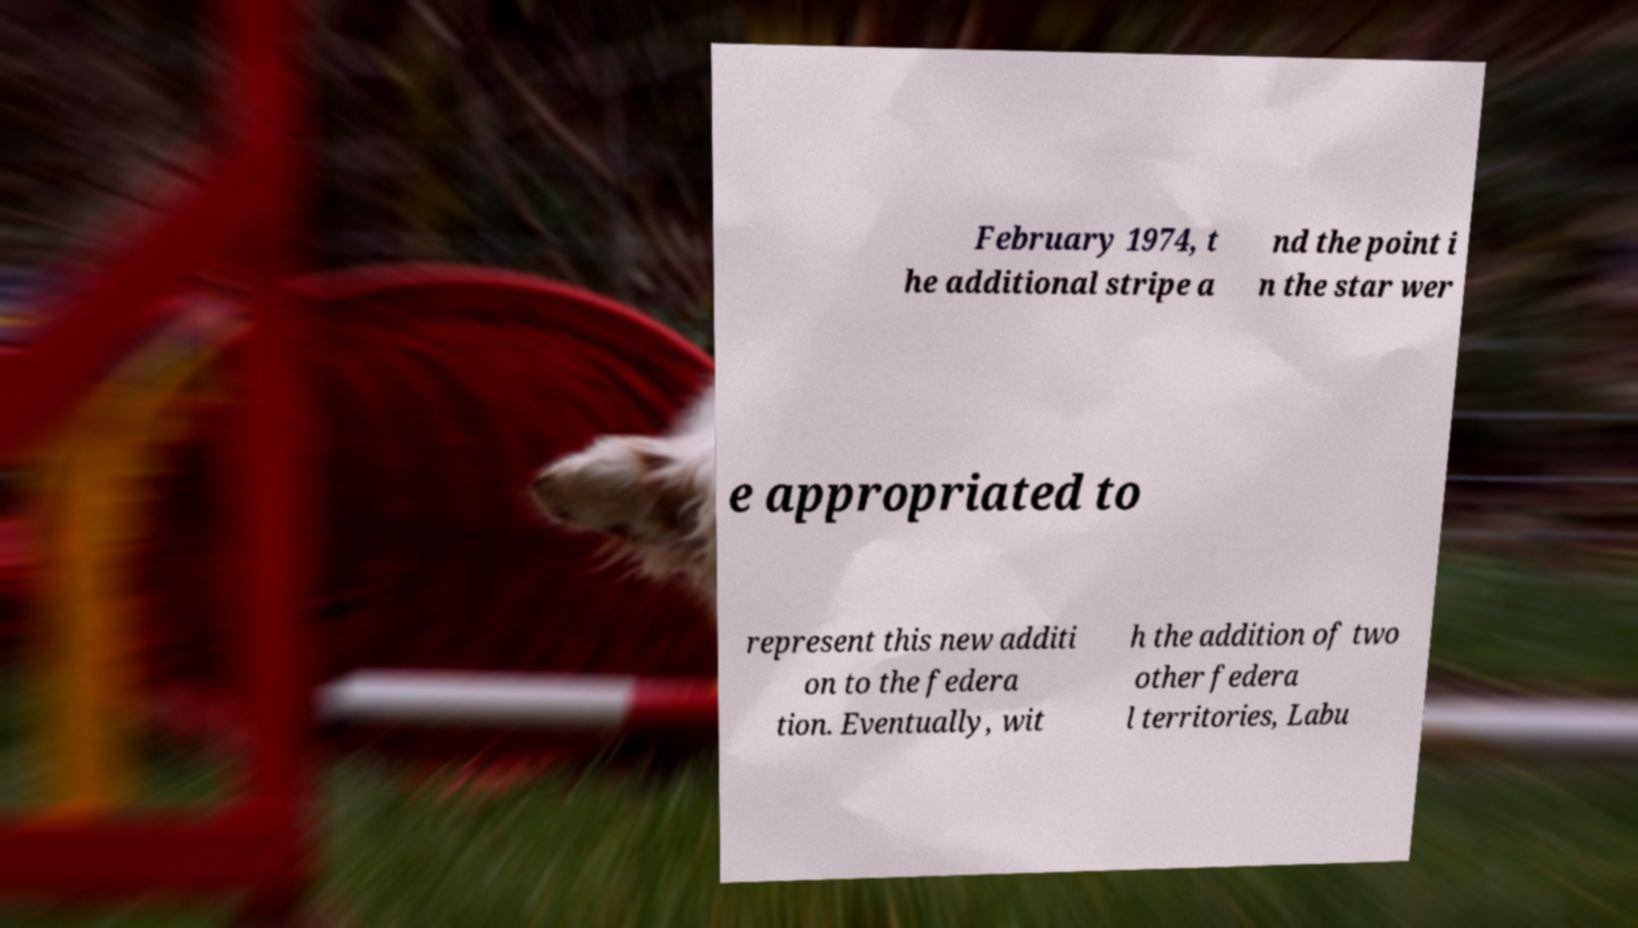I need the written content from this picture converted into text. Can you do that? February 1974, t he additional stripe a nd the point i n the star wer e appropriated to represent this new additi on to the federa tion. Eventually, wit h the addition of two other federa l territories, Labu 